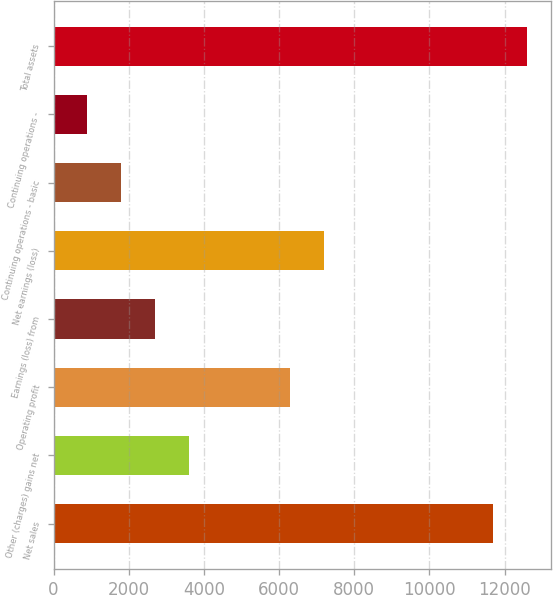Convert chart to OTSL. <chart><loc_0><loc_0><loc_500><loc_500><bar_chart><fcel>Net sales<fcel>Other (charges) gains net<fcel>Operating profit<fcel>Earnings (loss) from<fcel>Net earnings (loss)<fcel>Continuing operations - basic<fcel>Continuing operations -<fcel>Total assets<nl><fcel>11699.9<fcel>3600.15<fcel>6300.06<fcel>2700.18<fcel>7200.03<fcel>1800.21<fcel>900.24<fcel>12599.9<nl></chart> 